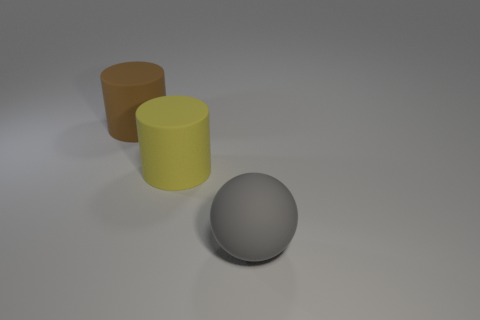Subtract all yellow cylinders. How many cylinders are left? 1 Subtract 1 cylinders. How many cylinders are left? 1 Add 1 large purple shiny objects. How many objects exist? 4 Subtract all spheres. How many objects are left? 2 Subtract all gray cubes. How many yellow cylinders are left? 1 Subtract all large brown rubber cylinders. Subtract all gray objects. How many objects are left? 1 Add 2 matte spheres. How many matte spheres are left? 3 Add 2 big gray balls. How many big gray balls exist? 3 Subtract 0 red spheres. How many objects are left? 3 Subtract all green cylinders. Subtract all cyan cubes. How many cylinders are left? 2 